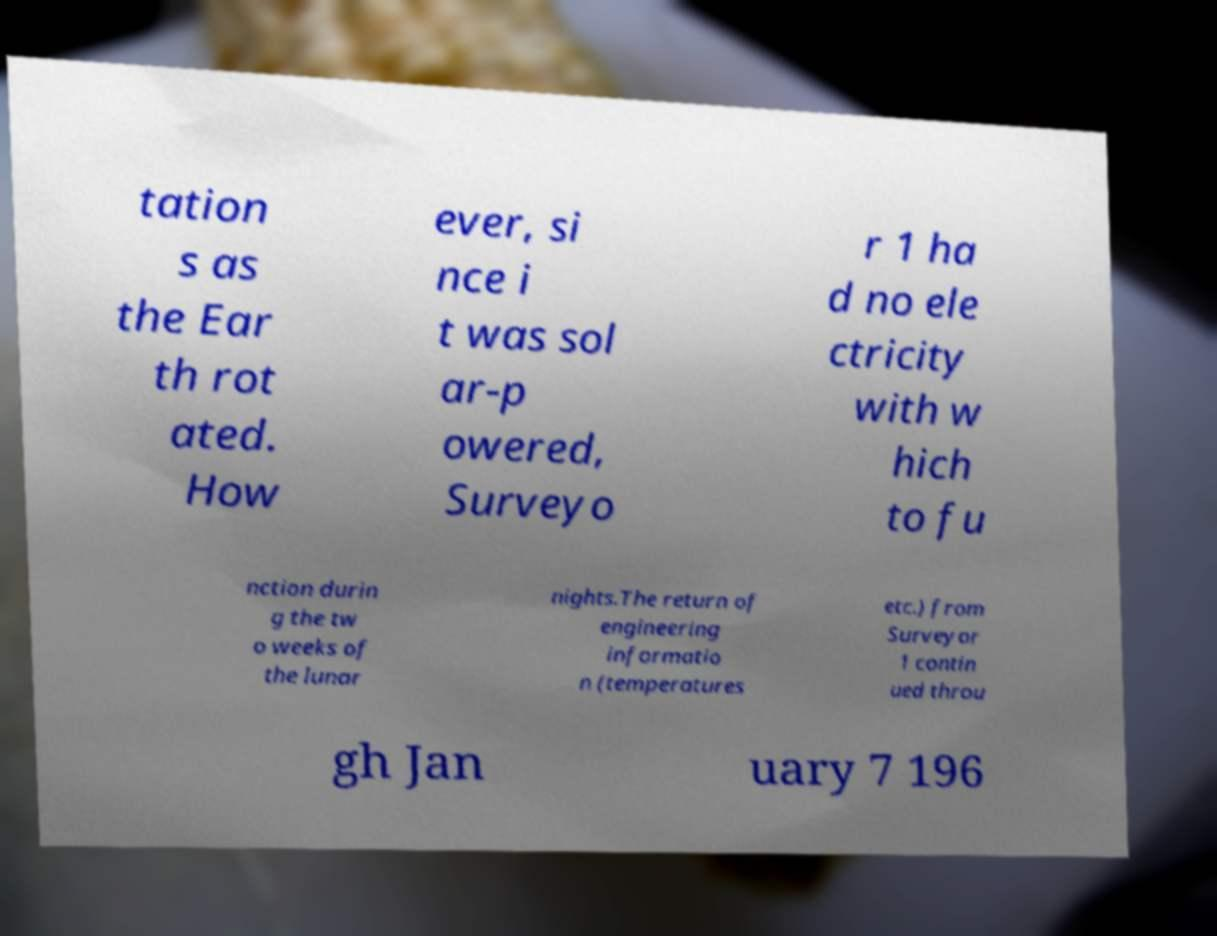Can you accurately transcribe the text from the provided image for me? tation s as the Ear th rot ated. How ever, si nce i t was sol ar-p owered, Surveyo r 1 ha d no ele ctricity with w hich to fu nction durin g the tw o weeks of the lunar nights.The return of engineering informatio n (temperatures etc.) from Surveyor 1 contin ued throu gh Jan uary 7 196 